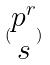<formula> <loc_0><loc_0><loc_500><loc_500>( \begin{matrix} p ^ { r } \\ s \end{matrix} )</formula> 